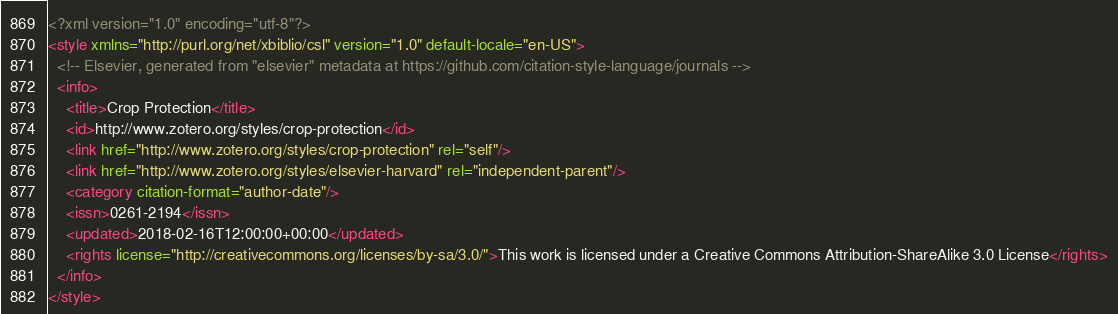Convert code to text. <code><loc_0><loc_0><loc_500><loc_500><_XML_><?xml version="1.0" encoding="utf-8"?>
<style xmlns="http://purl.org/net/xbiblio/csl" version="1.0" default-locale="en-US">
  <!-- Elsevier, generated from "elsevier" metadata at https://github.com/citation-style-language/journals -->
  <info>
    <title>Crop Protection</title>
    <id>http://www.zotero.org/styles/crop-protection</id>
    <link href="http://www.zotero.org/styles/crop-protection" rel="self"/>
    <link href="http://www.zotero.org/styles/elsevier-harvard" rel="independent-parent"/>
    <category citation-format="author-date"/>
    <issn>0261-2194</issn>
    <updated>2018-02-16T12:00:00+00:00</updated>
    <rights license="http://creativecommons.org/licenses/by-sa/3.0/">This work is licensed under a Creative Commons Attribution-ShareAlike 3.0 License</rights>
  </info>
</style>
</code> 